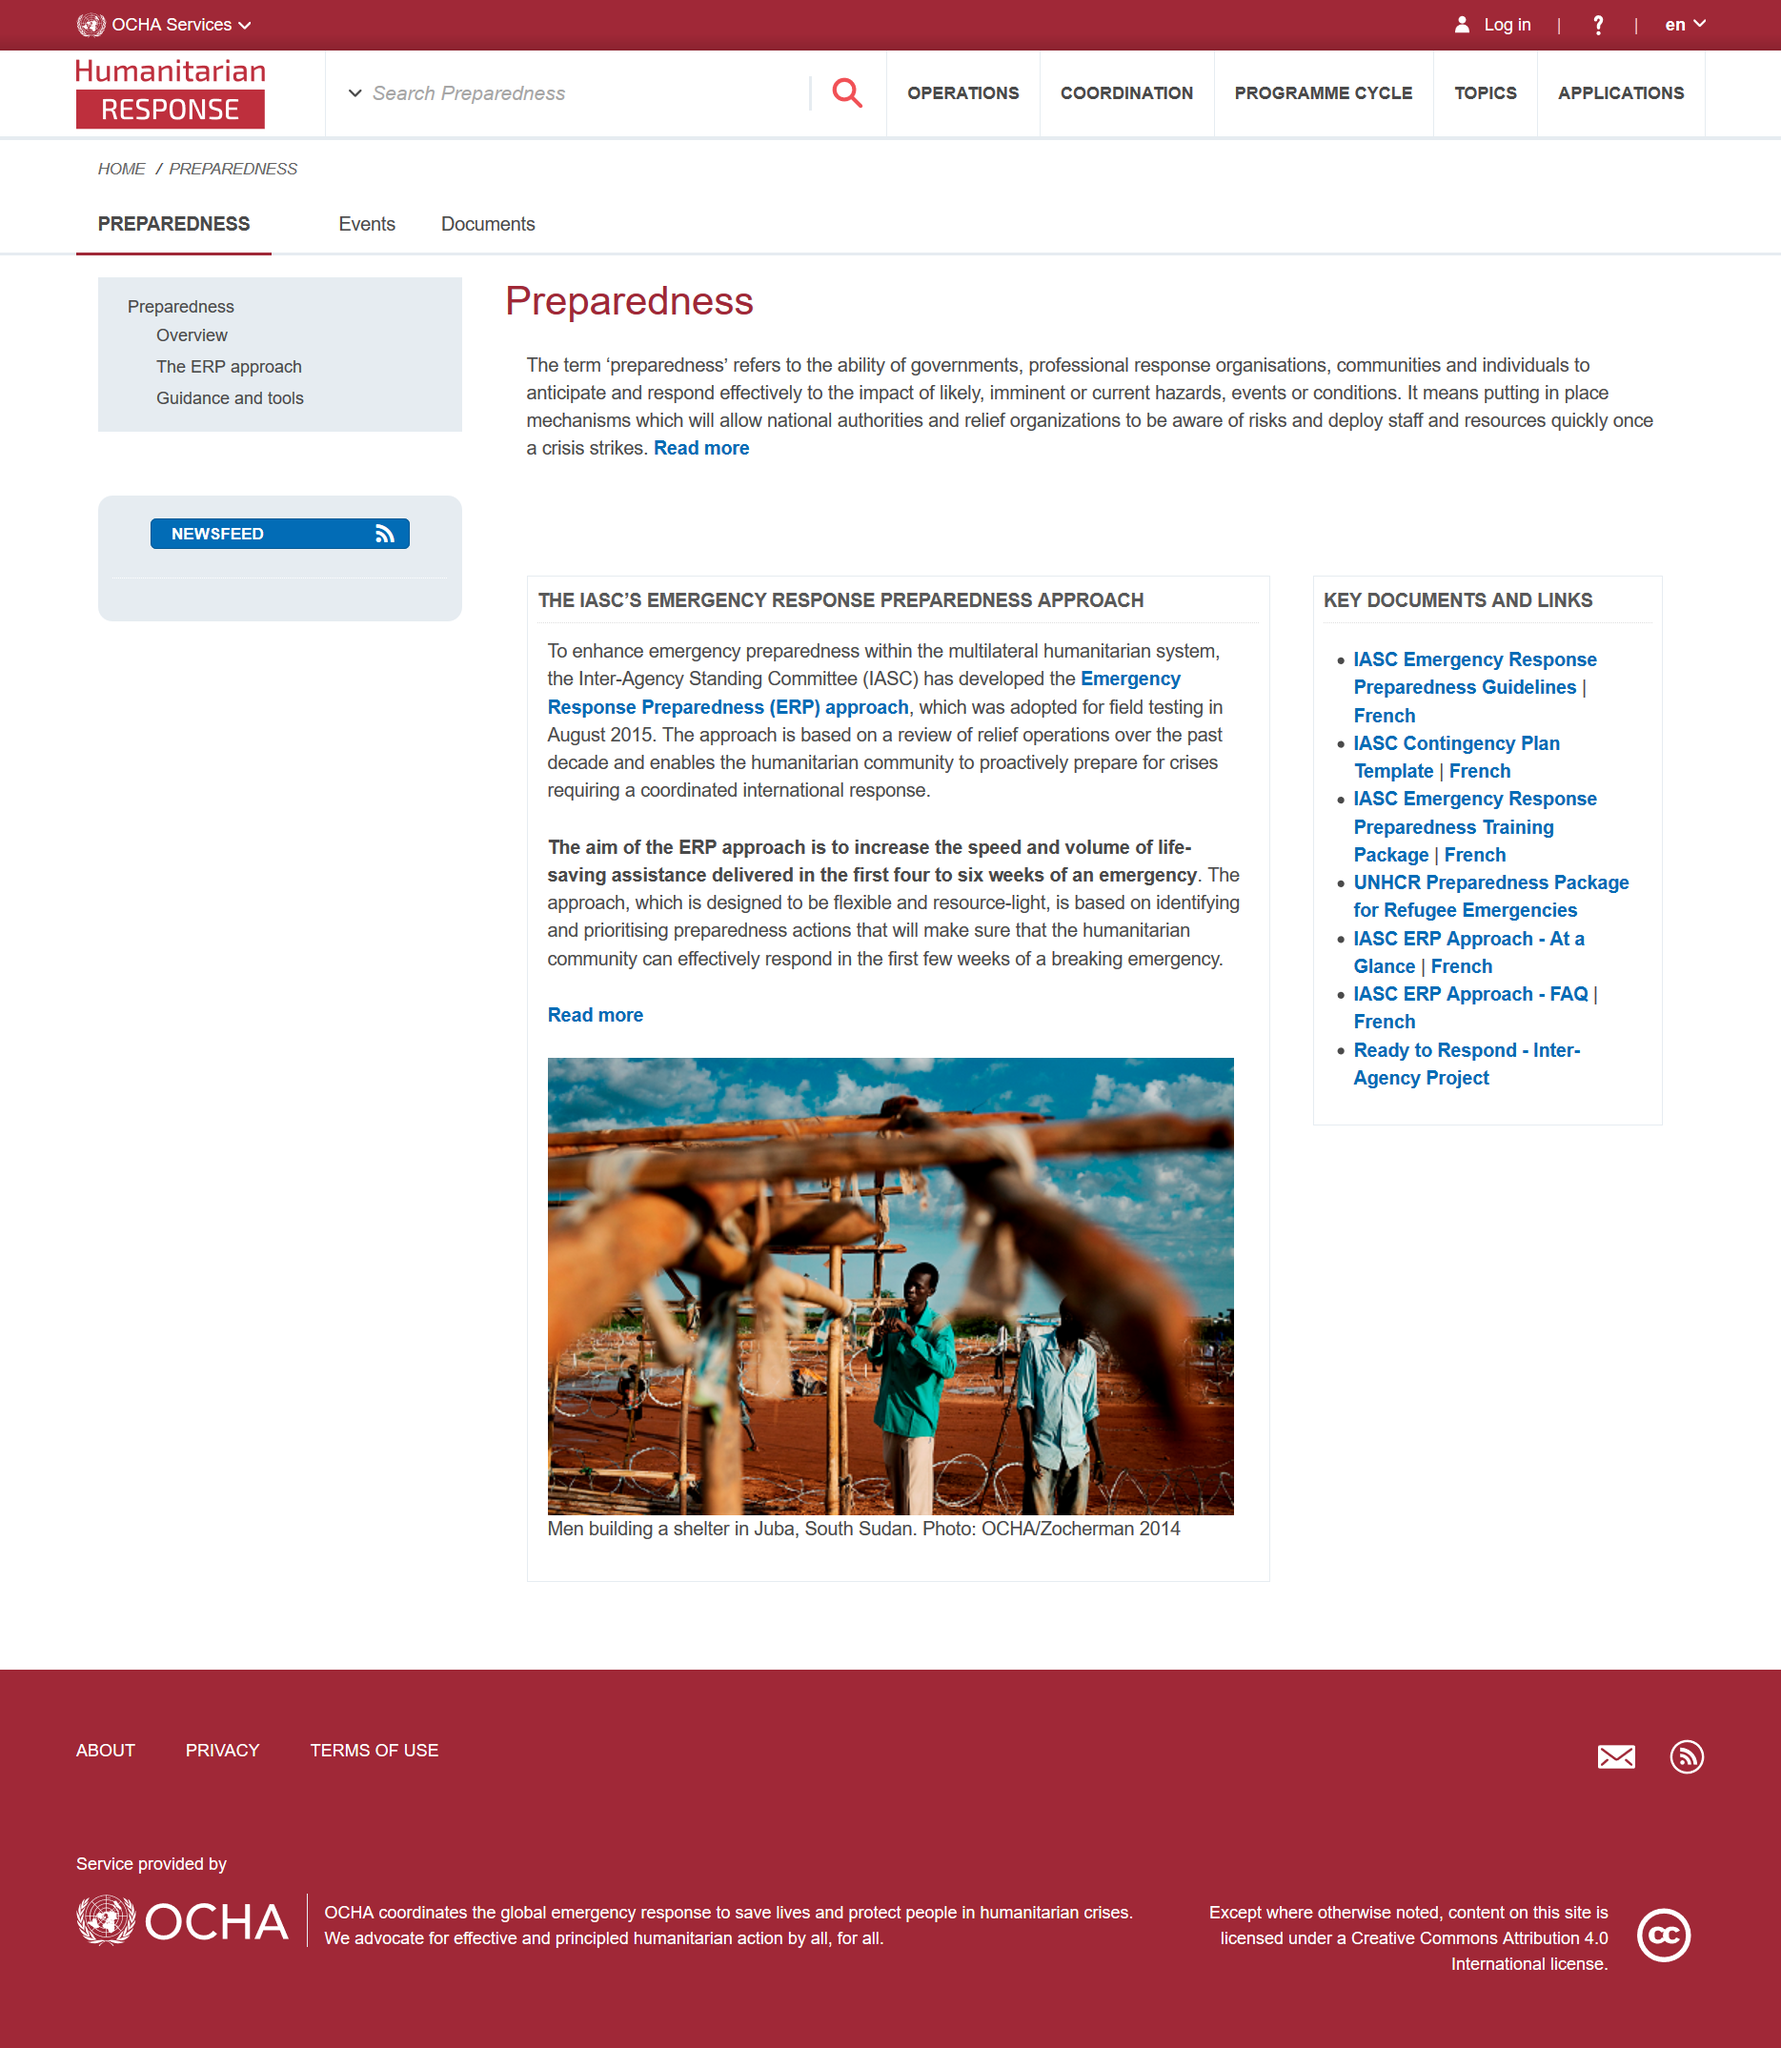Highlight a few significant elements in this photo. The article stub refers to the concept of preparedness. Preparedness benefits national authorities and relief organizations. Preparedness is a vital aspect in ensuring the readiness of national authorities and relief organizations to effectively respond to potential risks and disasters. 